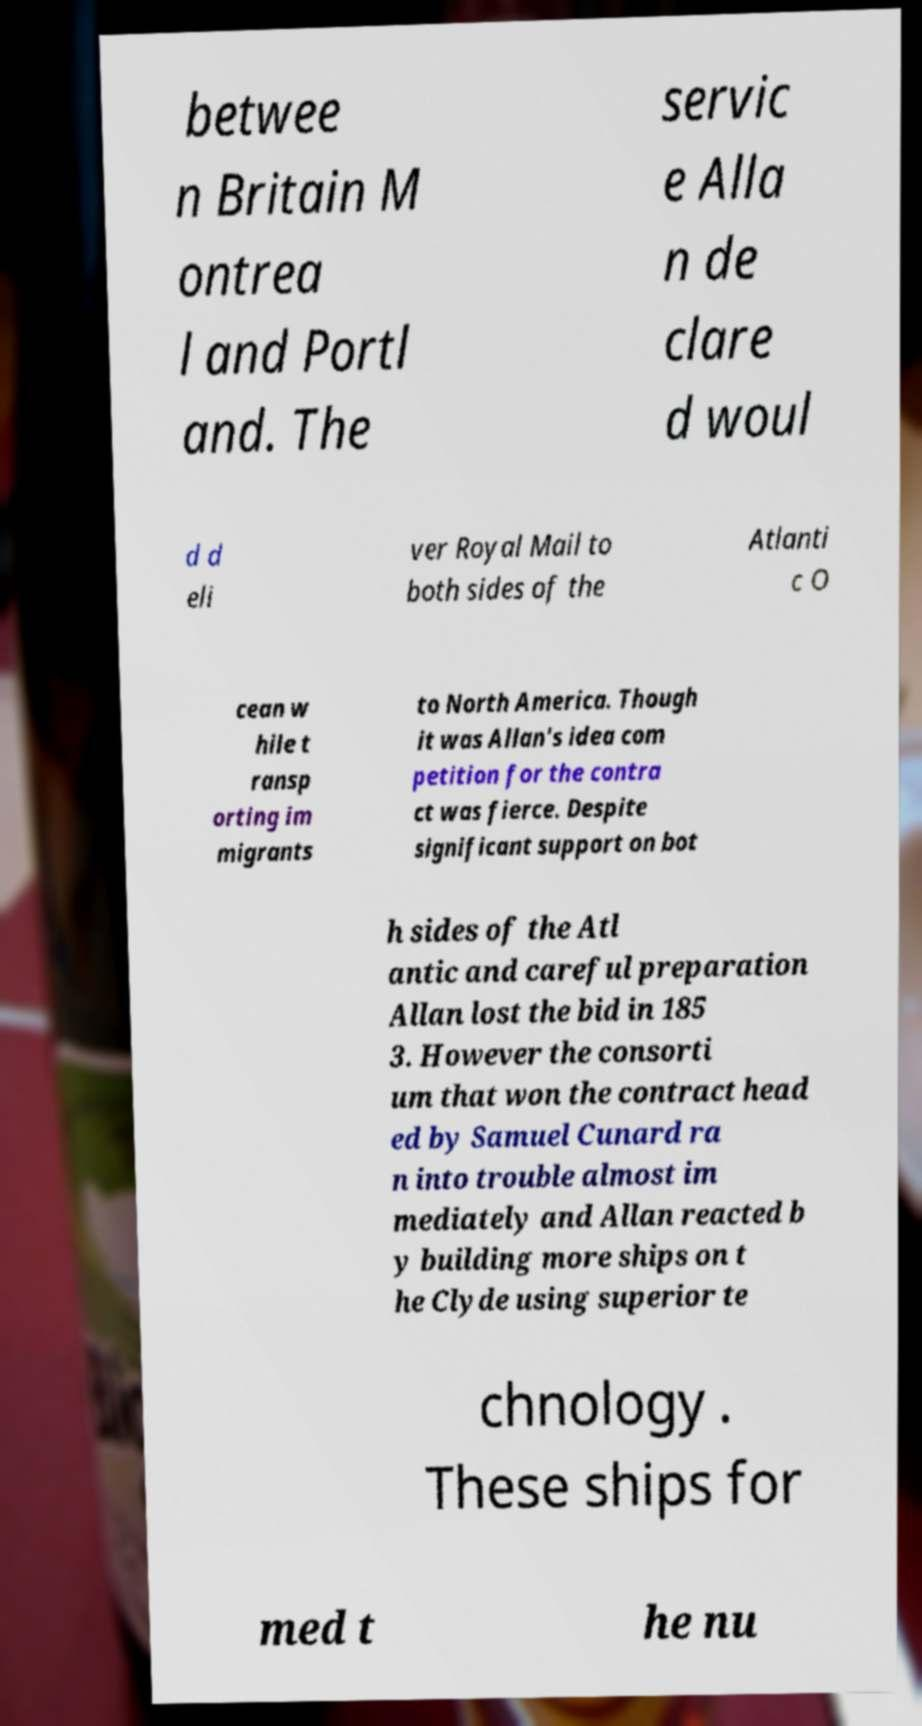Can you read and provide the text displayed in the image?This photo seems to have some interesting text. Can you extract and type it out for me? betwee n Britain M ontrea l and Portl and. The servic e Alla n de clare d woul d d eli ver Royal Mail to both sides of the Atlanti c O cean w hile t ransp orting im migrants to North America. Though it was Allan's idea com petition for the contra ct was fierce. Despite significant support on bot h sides of the Atl antic and careful preparation Allan lost the bid in 185 3. However the consorti um that won the contract head ed by Samuel Cunard ra n into trouble almost im mediately and Allan reacted b y building more ships on t he Clyde using superior te chnology . These ships for med t he nu 